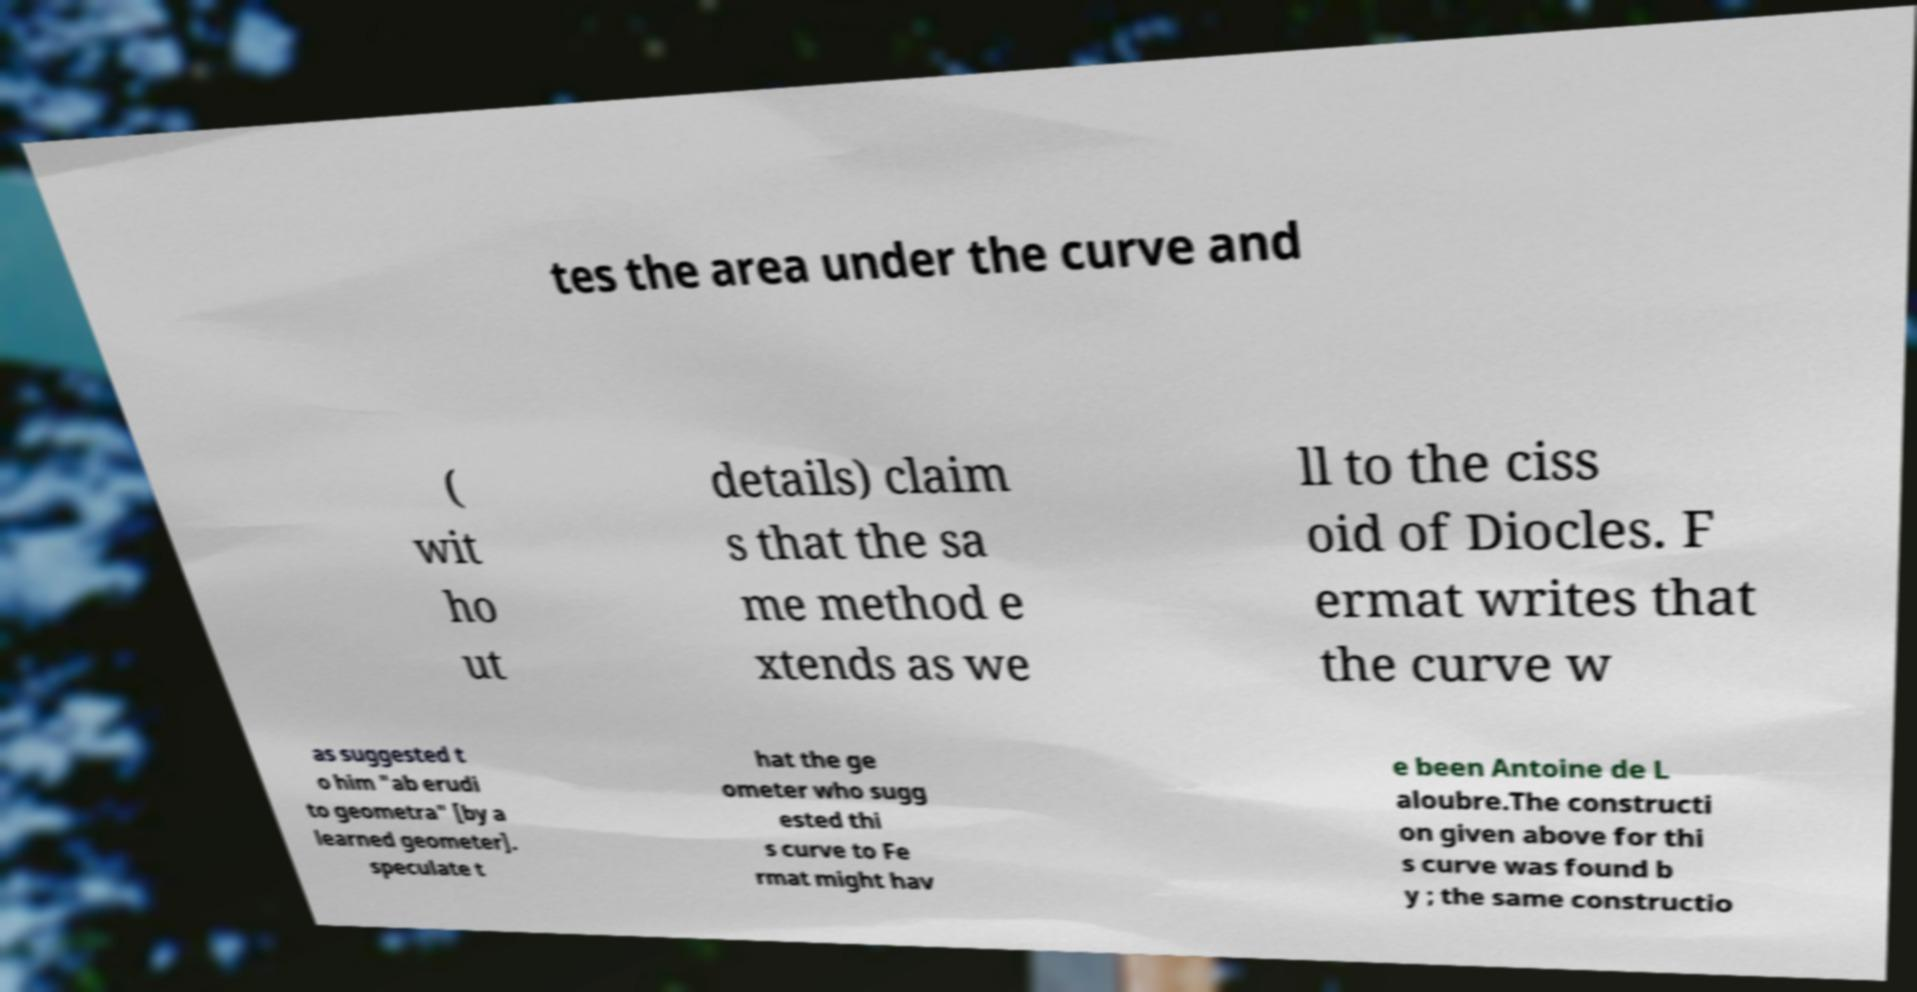Could you extract and type out the text from this image? tes the area under the curve and ( wit ho ut details) claim s that the sa me method e xtends as we ll to the ciss oid of Diocles. F ermat writes that the curve w as suggested t o him "ab erudi to geometra" [by a learned geometer]. speculate t hat the ge ometer who sugg ested thi s curve to Fe rmat might hav e been Antoine de L aloubre.The constructi on given above for thi s curve was found b y ; the same constructio 